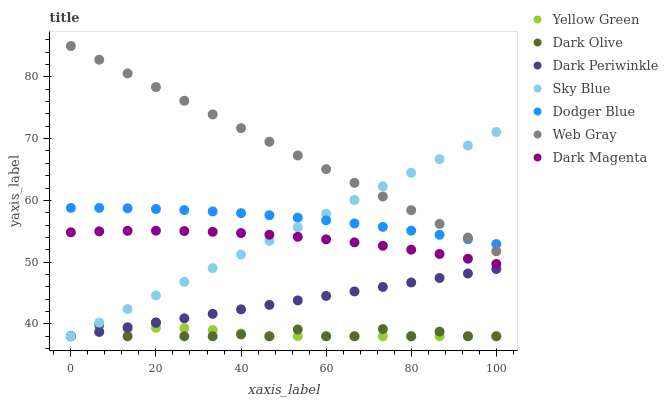Does Yellow Green have the minimum area under the curve?
Answer yes or no. Yes. Does Web Gray have the maximum area under the curve?
Answer yes or no. Yes. Does Dark Olive have the minimum area under the curve?
Answer yes or no. No. Does Dark Olive have the maximum area under the curve?
Answer yes or no. No. Is Sky Blue the smoothest?
Answer yes or no. Yes. Is Dark Olive the roughest?
Answer yes or no. Yes. Is Yellow Green the smoothest?
Answer yes or no. No. Is Yellow Green the roughest?
Answer yes or no. No. Does Yellow Green have the lowest value?
Answer yes or no. Yes. Does Dodger Blue have the lowest value?
Answer yes or no. No. Does Web Gray have the highest value?
Answer yes or no. Yes. Does Dark Olive have the highest value?
Answer yes or no. No. Is Dark Periwinkle less than Web Gray?
Answer yes or no. Yes. Is Web Gray greater than Dark Magenta?
Answer yes or no. Yes. Does Yellow Green intersect Dark Olive?
Answer yes or no. Yes. Is Yellow Green less than Dark Olive?
Answer yes or no. No. Is Yellow Green greater than Dark Olive?
Answer yes or no. No. Does Dark Periwinkle intersect Web Gray?
Answer yes or no. No. 